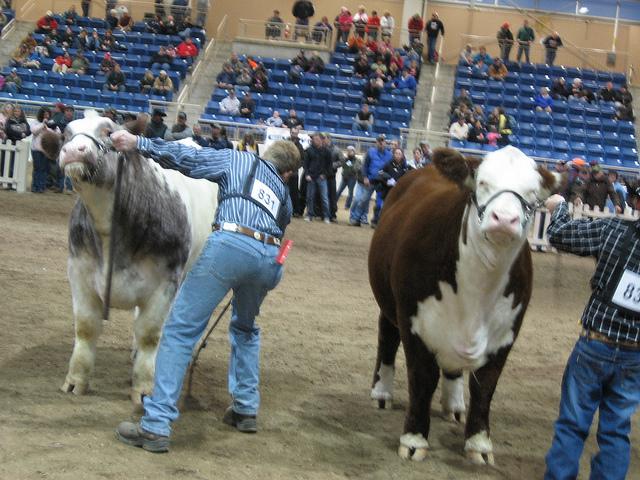Where is this?
Answer briefly. Rodeo. Is this a photo of a bovine competition?
Write a very short answer. Yes. What color is the cow on the right?
Write a very short answer. Brown and white. What number is on the man's back on the left?
Quick response, please. 831. What animal is the boy riding?
Answer briefly. Cow. Where is the boy wearing a red cap?
Be succinct. Bleachers. 